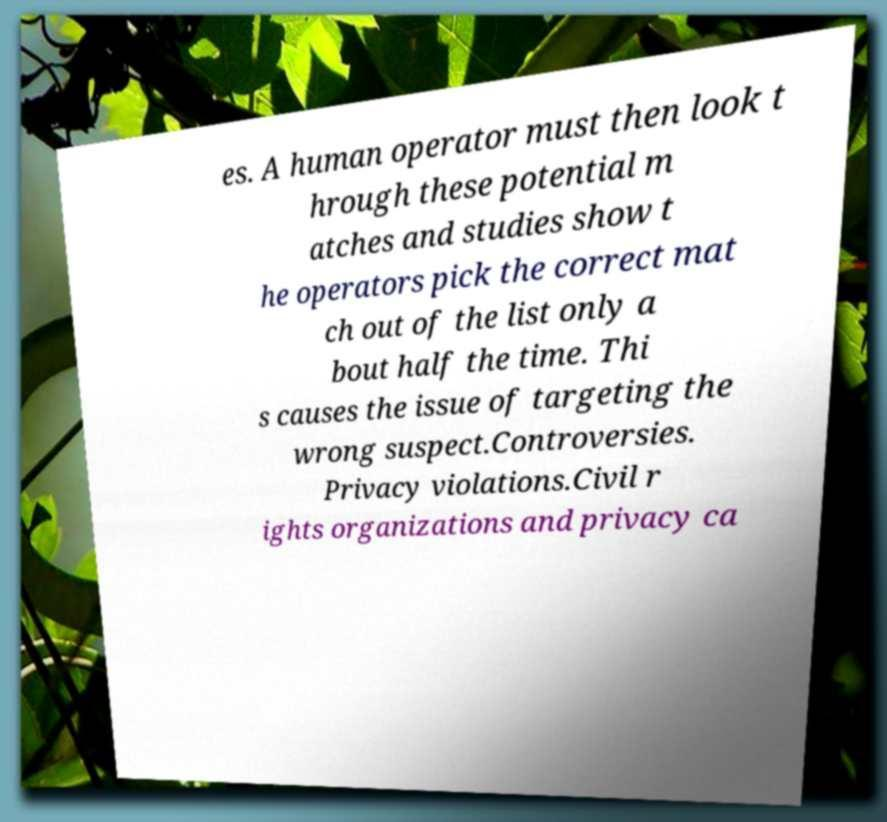Can you accurately transcribe the text from the provided image for me? es. A human operator must then look t hrough these potential m atches and studies show t he operators pick the correct mat ch out of the list only a bout half the time. Thi s causes the issue of targeting the wrong suspect.Controversies. Privacy violations.Civil r ights organizations and privacy ca 